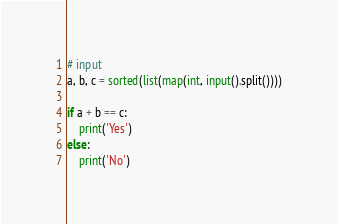<code> <loc_0><loc_0><loc_500><loc_500><_Python_># input
a, b, c = sorted(list(map(int, input().split())))

if a + b == c:
    print('Yes')
else:
    print('No')


</code> 